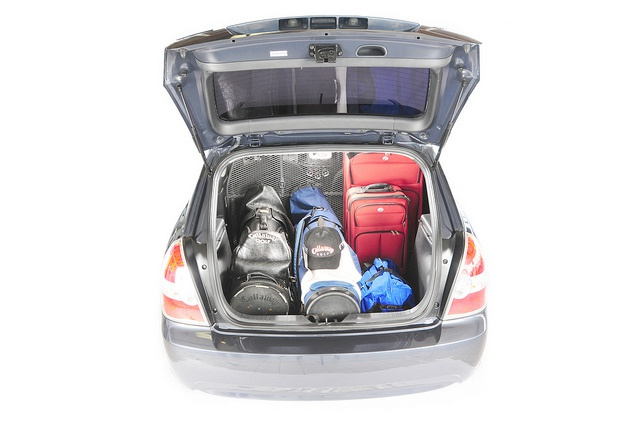Describe the objects in this image and their specific colors. I can see car in white, lightgray, gray, darkgray, and black tones, handbag in white, gray, darkgray, black, and lightgray tones, backpack in white, darkgray, and gray tones, handbag in white, darkgray, gray, and lightblue tones, and suitcase in white, salmon, brown, and maroon tones in this image. 